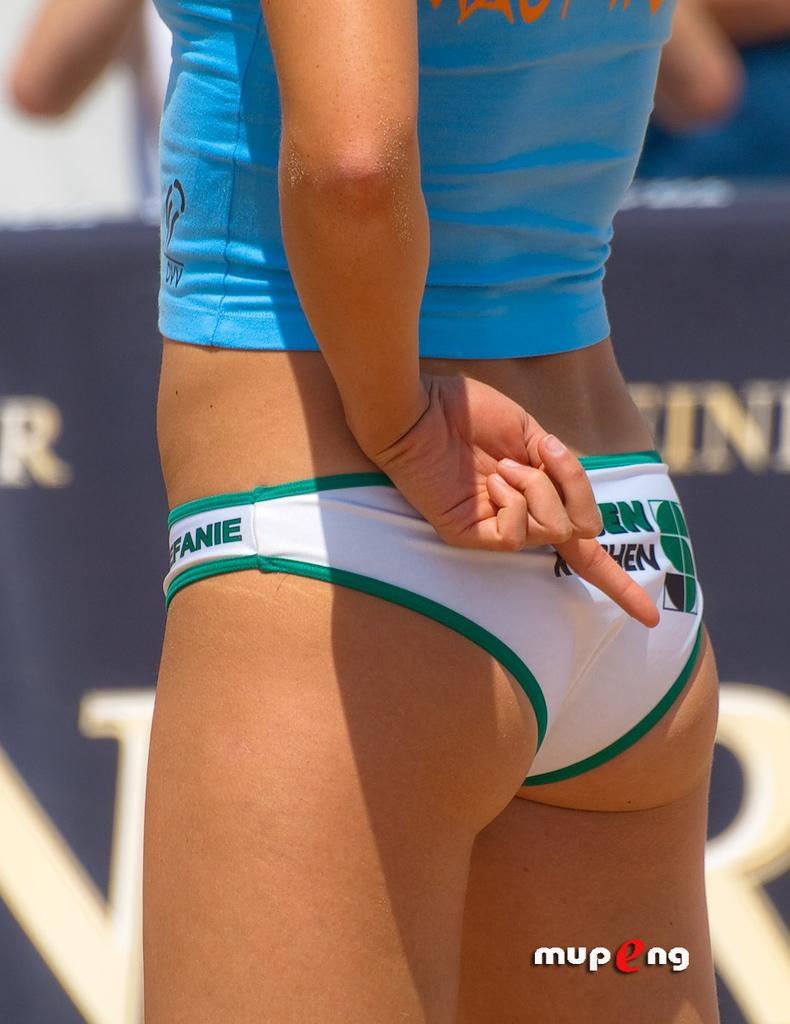<image>
Offer a succinct explanation of the picture presented. Only the letter EN can be seen on the bikini bottom, behind her hand that is flipping the bird. 